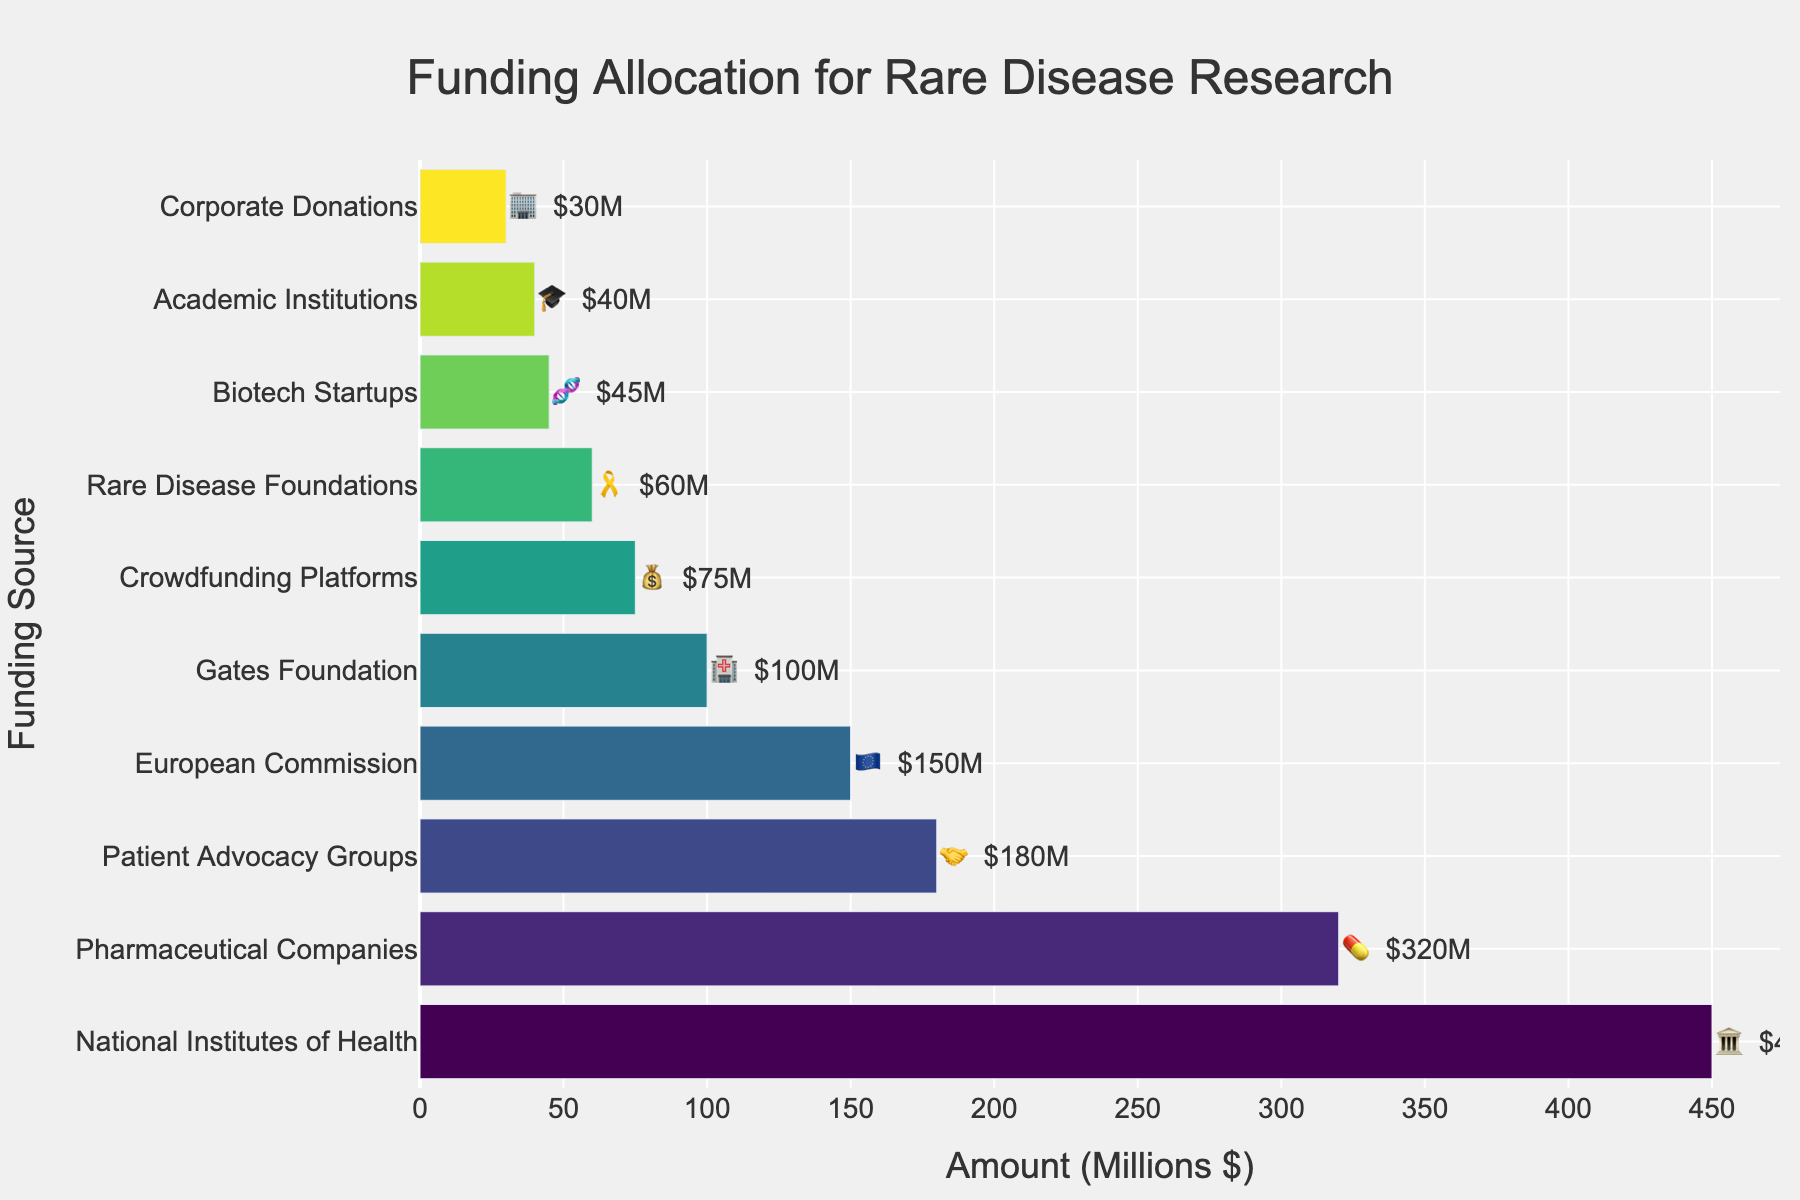What's the title of the chart? The title is usually found at the top center of the chart. Here, it reads "Funding Allocation for Rare Disease Research".
Answer: Funding Allocation for Rare Disease Research Which funding source has allocated the highest amount? The bar with the highest value represents the highest funding source. In this case, the National Institutes of Health with $450M is the highest.
Answer: National Institutes of Health How much funding did Pharmaceutical Companies allocate? Look for the bar labeled "Pharmaceutical Companies" and check the associated value. It shows $320M.
Answer: $320M Which funding source has the least amount of funding, and how much is it? The smallest bar represents the least funding. It is "Corporate Donations" with $30M.
Answer: Corporate Donations, $30M What is the total amount of funding from all sources? Sum all the values: 450 + 320 + 180 + 150 + 100 + 75 + 60 + 45 + 40 + 30, which equals 1450M.
Answer: $1450M Which funding sources are less than $50M, and what are their amounts? Identify bars below the $50M mark. "Biotech Startups" with $45M, "Academic Institutions" with $40M, and "Corporate Donations" with $30M meet this criterion.
Answer: Biotech Startups ($45M), Academic Institutions ($40M), Corporate Donations ($30M) How does the funding from Crowdfunding Platforms compare to the funding from the Gates Foundation? Compare the heights of the bars labeled "Crowdfunding Platforms" and "Gates Foundation". Crowdfunding Platforms have $75M and Gates Foundation has $100M, so Gates Foundation has more funding.
Answer: Gates Foundation is $25M more What is the average funding amount across all sources? Add all amounts (1450M) and divide by the number of sources (10). 1450M / 10 = $145M.
Answer: $145M Which funding source is represented by the 🤝 emoji and how much did it allocate? Look for the emoji 🤝 in the chart. It corresponds to Patient Advocacy Groups, which allocated $180M.
Answer: Patient Advocacy Groups, $180M Order the top three funding sources by amount allocated. Identify the top three highest bars: National Institutes of Health ($450M), Pharmaceutical Companies ($320M), and Patient Advocacy Groups ($180M).
Answer: National Institutes of Health, Pharmaceutical Companies, Patient Advocacy Groups 